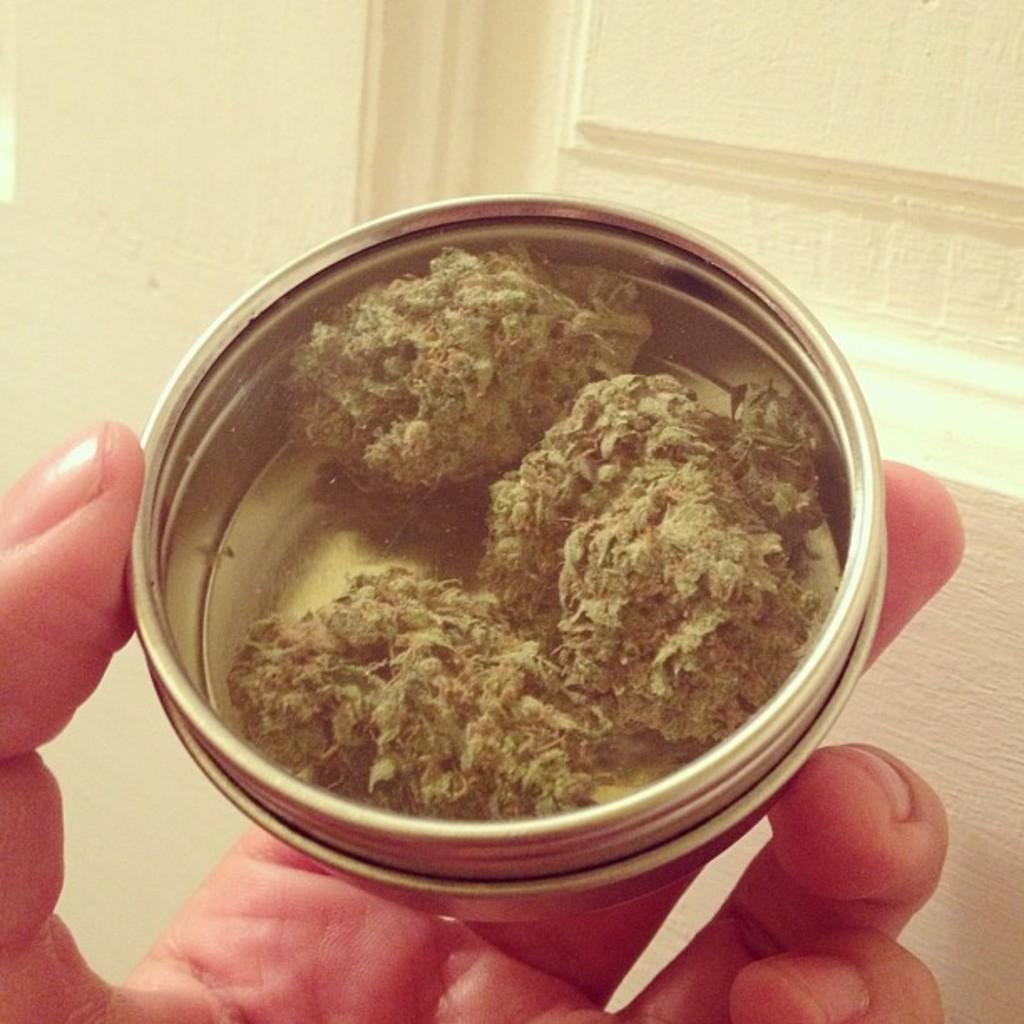What part of a person can be seen in the image? There is a hand visible in the image. What is the hand doing in the image? A person is holding an object in the image. What type of bucket is the spy using to collect the reward in the image? There is no bucket, spy, or reward present in the image. 